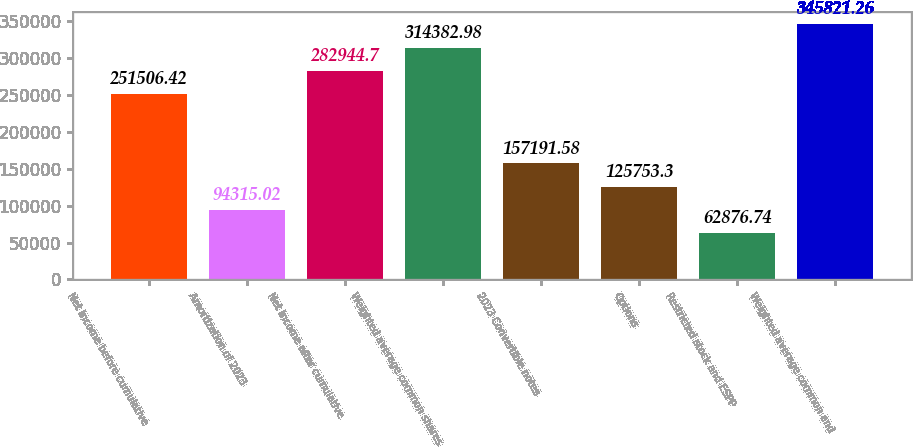<chart> <loc_0><loc_0><loc_500><loc_500><bar_chart><fcel>Net income before cumulative<fcel>Amortization of 2023<fcel>Net income after cumulative<fcel>Weighted average common shares<fcel>2023 Convertible notes<fcel>Options<fcel>Restricted stock and ESPP<fcel>Weighted average common and<nl><fcel>251506<fcel>94315<fcel>282945<fcel>314383<fcel>157192<fcel>125753<fcel>62876.7<fcel>345821<nl></chart> 